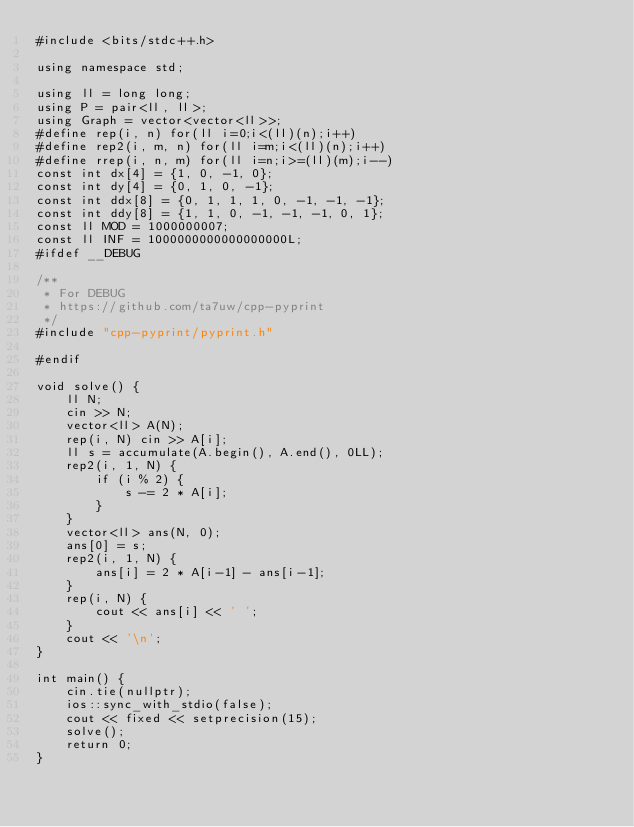Convert code to text. <code><loc_0><loc_0><loc_500><loc_500><_C++_>#include <bits/stdc++.h>

using namespace std;

using ll = long long;
using P = pair<ll, ll>;
using Graph = vector<vector<ll>>;
#define rep(i, n) for(ll i=0;i<(ll)(n);i++)
#define rep2(i, m, n) for(ll i=m;i<(ll)(n);i++)
#define rrep(i, n, m) for(ll i=n;i>=(ll)(m);i--)
const int dx[4] = {1, 0, -1, 0};
const int dy[4] = {0, 1, 0, -1};
const int ddx[8] = {0, 1, 1, 1, 0, -1, -1, -1};
const int ddy[8] = {1, 1, 0, -1, -1, -1, 0, 1};
const ll MOD = 1000000007;
const ll INF = 1000000000000000000L;
#ifdef __DEBUG

/**
 * For DEBUG
 * https://github.com/ta7uw/cpp-pyprint
 */
#include "cpp-pyprint/pyprint.h"

#endif

void solve() {
    ll N;
    cin >> N;
    vector<ll> A(N);
    rep(i, N) cin >> A[i];
    ll s = accumulate(A.begin(), A.end(), 0LL);
    rep2(i, 1, N) {
        if (i % 2) {
            s -= 2 * A[i];
        }
    }
    vector<ll> ans(N, 0);
    ans[0] = s;
    rep2(i, 1, N) {
        ans[i] = 2 * A[i-1] - ans[i-1];
    }
    rep(i, N) {
        cout << ans[i] << ' ';
    }
    cout << '\n';
}

int main() {
    cin.tie(nullptr);
    ios::sync_with_stdio(false);
    cout << fixed << setprecision(15);
    solve();
    return 0;
}
</code> 